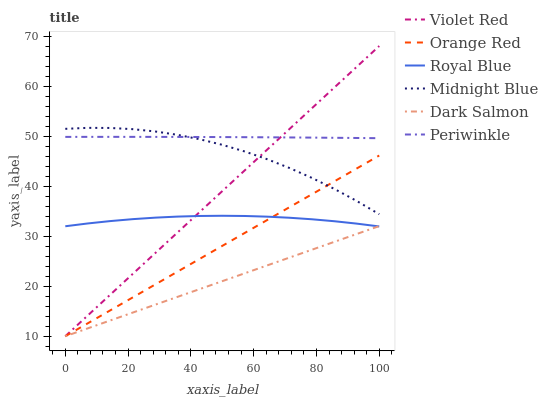Does Dark Salmon have the minimum area under the curve?
Answer yes or no. Yes. Does Midnight Blue have the minimum area under the curve?
Answer yes or no. No. Does Midnight Blue have the maximum area under the curve?
Answer yes or no. No. Is Dark Salmon the smoothest?
Answer yes or no. Yes. Is Midnight Blue the roughest?
Answer yes or no. Yes. Is Midnight Blue the smoothest?
Answer yes or no. No. Is Dark Salmon the roughest?
Answer yes or no. No. Does Midnight Blue have the lowest value?
Answer yes or no. No. Does Midnight Blue have the highest value?
Answer yes or no. No. Is Orange Red less than Periwinkle?
Answer yes or no. Yes. Is Midnight Blue greater than Dark Salmon?
Answer yes or no. Yes. Does Orange Red intersect Periwinkle?
Answer yes or no. No. 